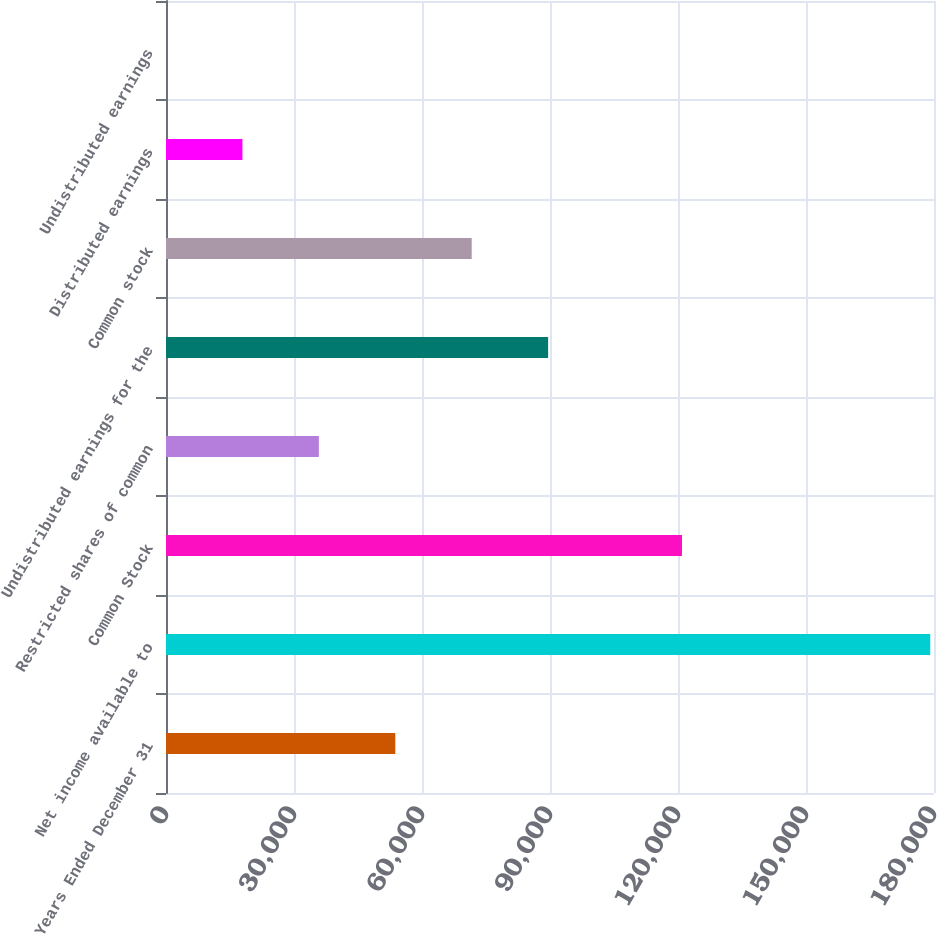<chart> <loc_0><loc_0><loc_500><loc_500><bar_chart><fcel>Years Ended December 31<fcel>Net income available to<fcel>Common Stock<fcel>Restricted shares of common<fcel>Undistributed earnings for the<fcel>Common stock<fcel>Distributed earnings<fcel>Undistributed earnings<nl><fcel>53737.4<fcel>179124<fcel>120930<fcel>35825<fcel>89562.1<fcel>71649.7<fcel>17912.6<fcel>0.26<nl></chart> 